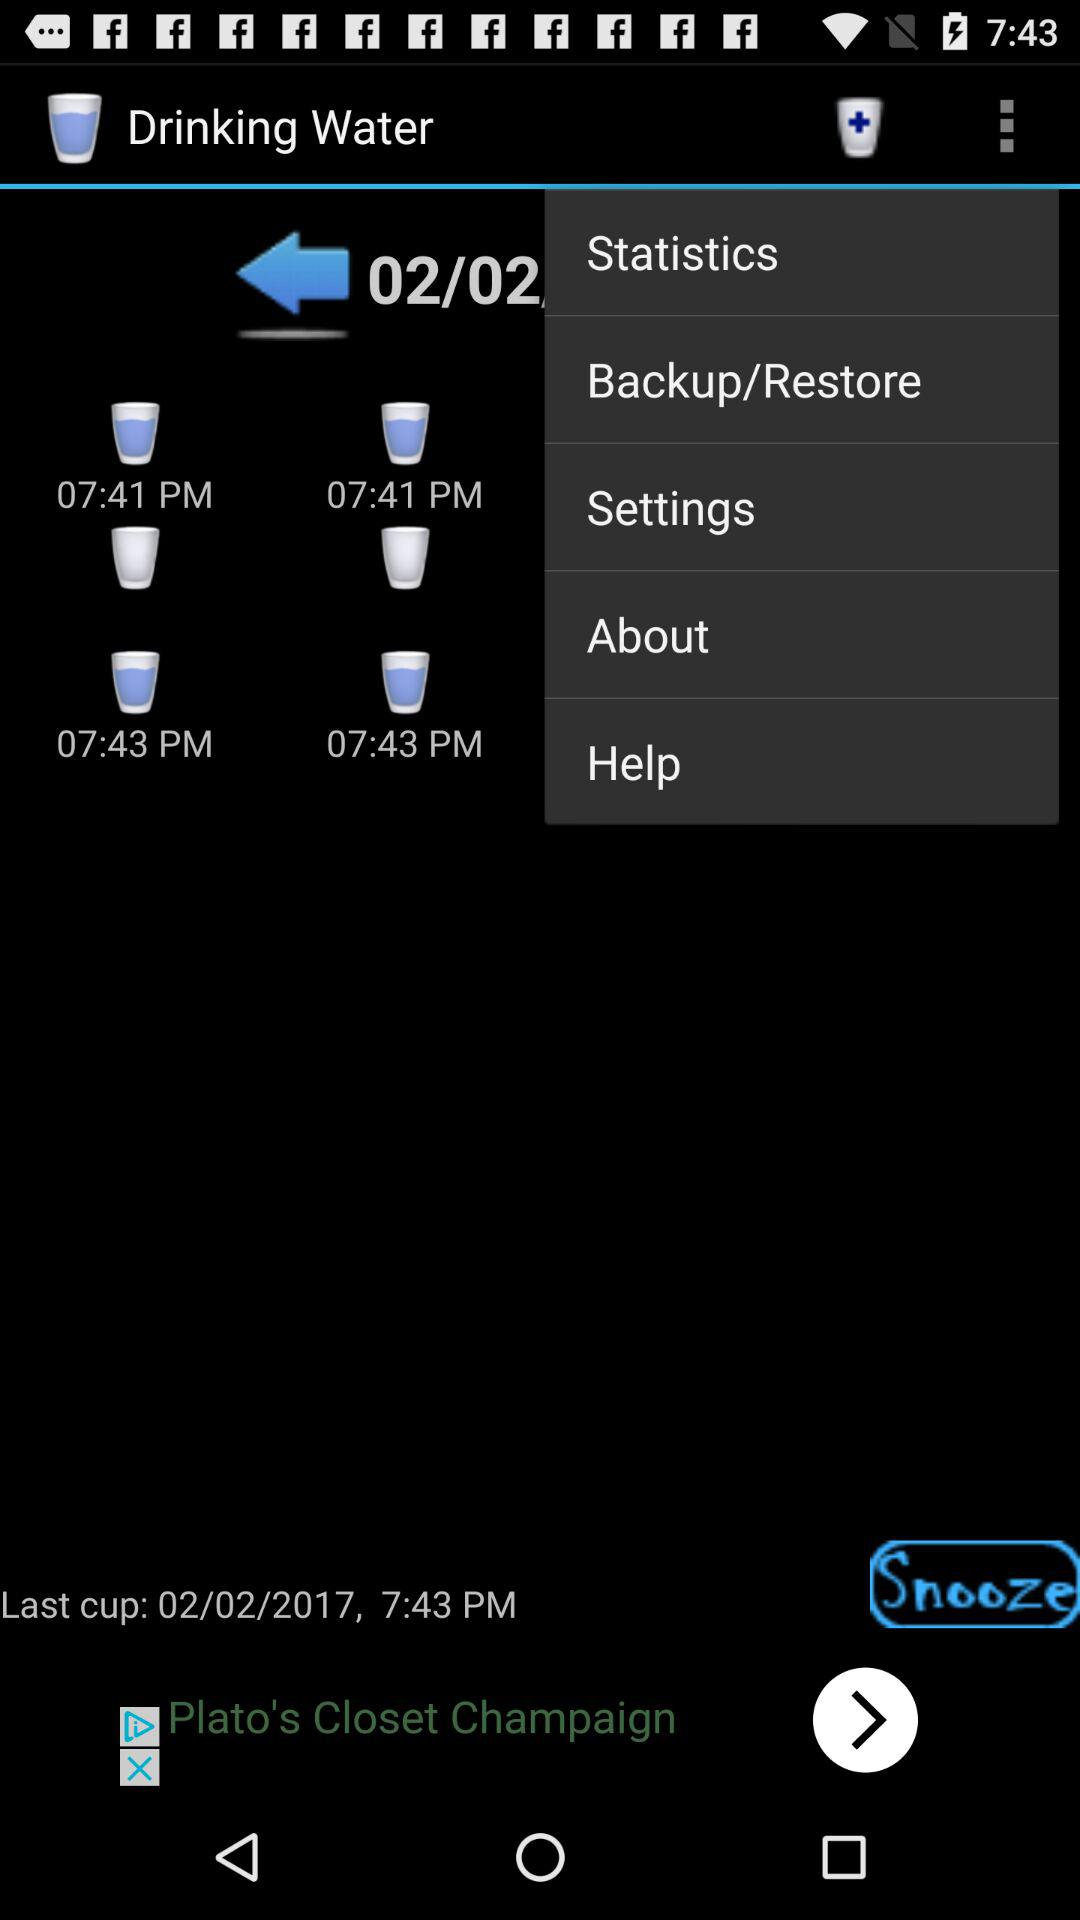When is the "Last cup" filled? The last cup was filled on February 2, 2017, at 7:43 PM. 